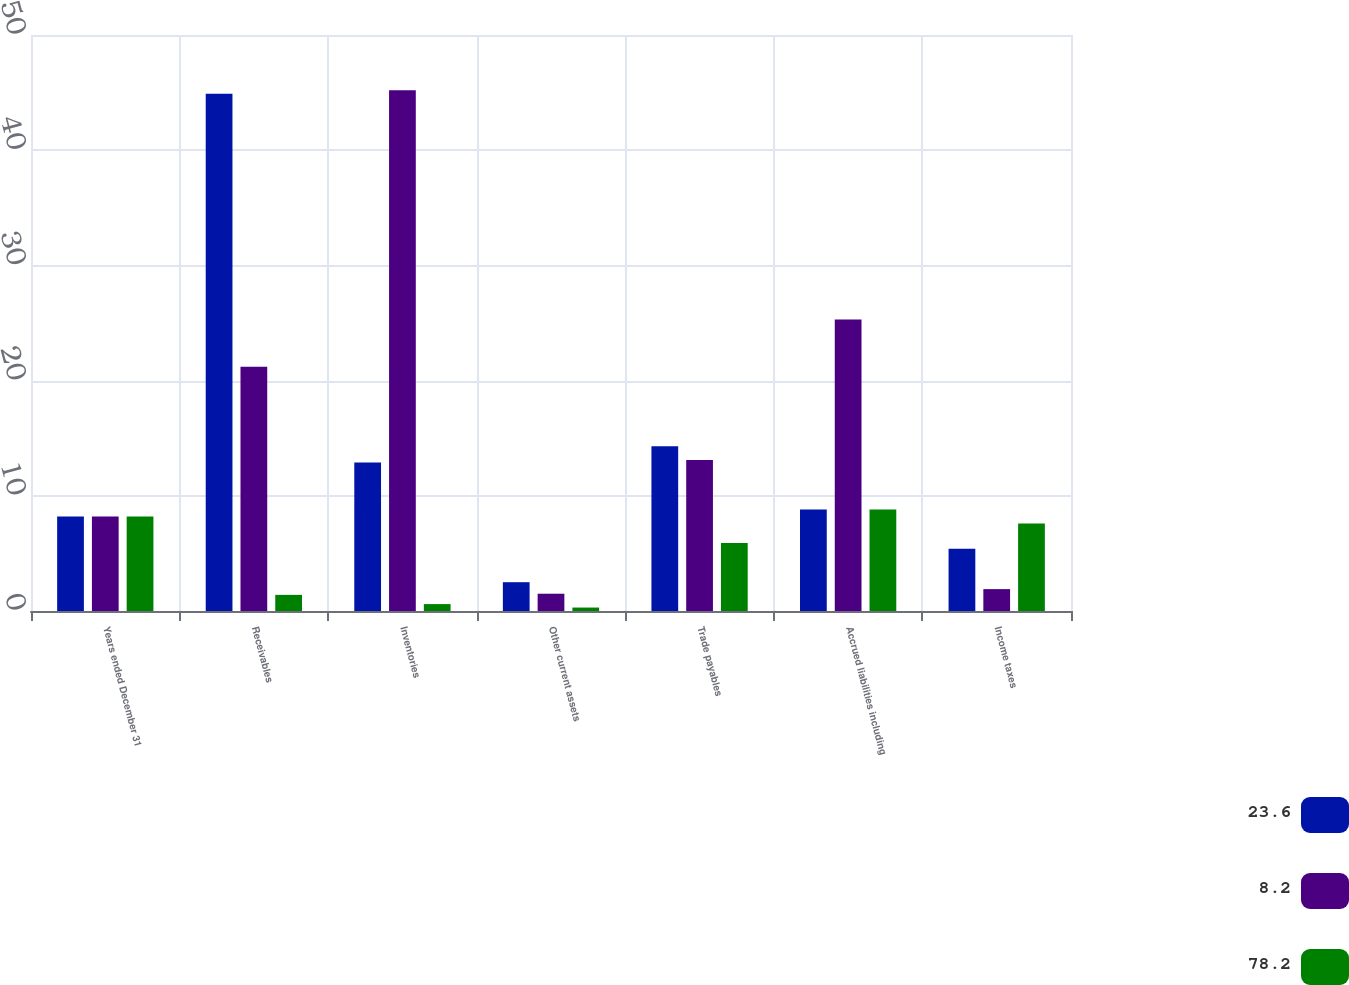Convert chart to OTSL. <chart><loc_0><loc_0><loc_500><loc_500><stacked_bar_chart><ecel><fcel>Years ended December 31<fcel>Receivables<fcel>Inventories<fcel>Other current assets<fcel>Trade payables<fcel>Accrued liabilities including<fcel>Income taxes<nl><fcel>23.6<fcel>8.2<fcel>44.9<fcel>12.9<fcel>2.5<fcel>14.3<fcel>8.8<fcel>5.4<nl><fcel>8.2<fcel>8.2<fcel>21.2<fcel>45.2<fcel>1.5<fcel>13.1<fcel>25.3<fcel>1.9<nl><fcel>78.2<fcel>8.2<fcel>1.4<fcel>0.6<fcel>0.3<fcel>5.9<fcel>8.8<fcel>7.6<nl></chart> 